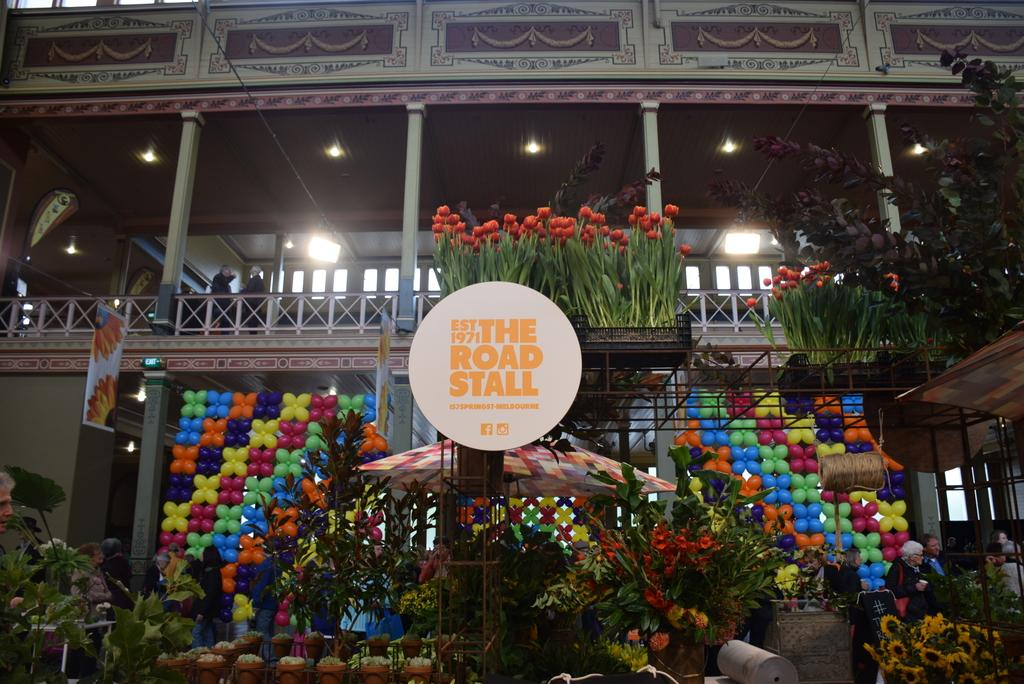What types of living organisms can be seen in the image? Plants and flowers are visible in the image. What additional objects can be seen in the image? There are balloons, pillars, and lights visible in the image. What type of loaf is being used to hold the balloons in the image? There is no loaf present in the image; the balloons are not being held by any type of loaf. 